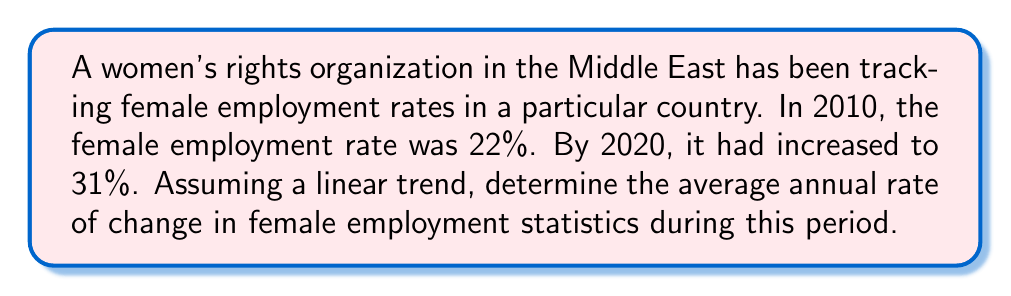Teach me how to tackle this problem. To solve this problem, we need to calculate the rate of change over time. We can use the slope formula:

$$m = \frac{\text{change in y}}{\text{change in x}}$$

Where:
- $m$ is the rate of change (slope)
- $y$ represents the female employment rate
- $x$ represents the year

Given:
- Initial year (2010): $x_1 = 2010$, $y_1 = 22\%$
- Final year (2020): $x_2 = 2020$, $y_2 = 31\%$

Let's calculate:

1) Change in y (employment rate):
   $\Delta y = y_2 - y_1 = 31\% - 22\% = 9\%$

2) Change in x (years):
   $\Delta x = x_2 - x_1 = 2020 - 2010 = 10$ years

3) Apply the slope formula:
   $$m = \frac{\Delta y}{\Delta x} = \frac{9\%}{10 \text{ years}} = 0.9\% \text{ per year}$$

Therefore, the average annual rate of change in female employment statistics is 0.9% per year.
Answer: 0.9% per year 